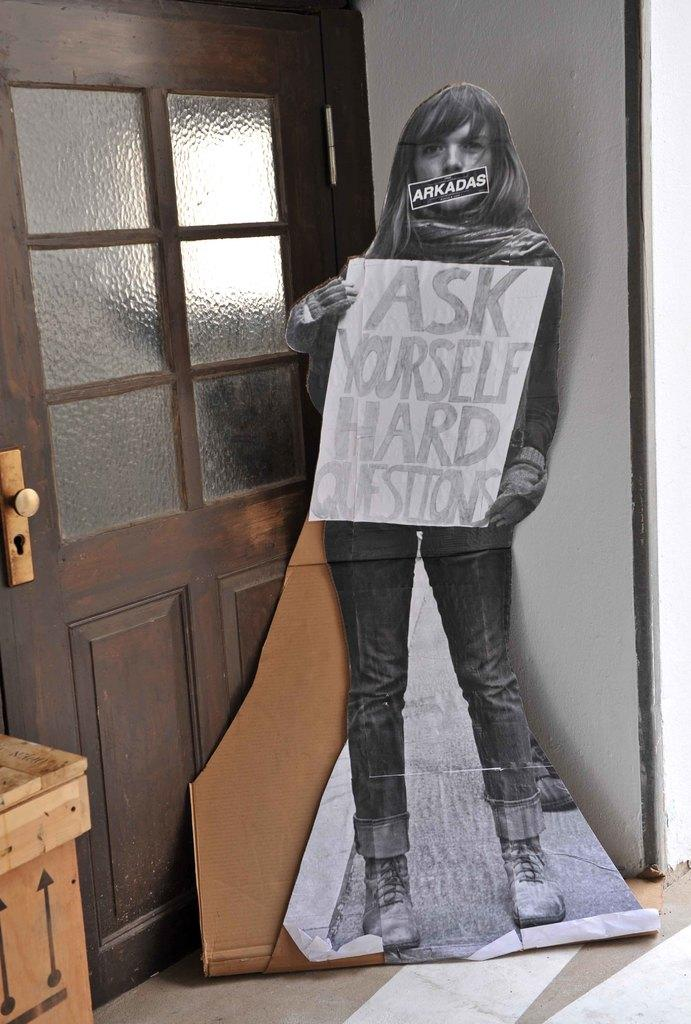What is the main object in the image? There is a board in the image. Where is the board located in relation to other objects? The board is placed beside a door and a wall. What type of bucket is hanging on the wall beside the board in the image? There is no bucket present in the image; it only features a board placed beside a door and a wall. 